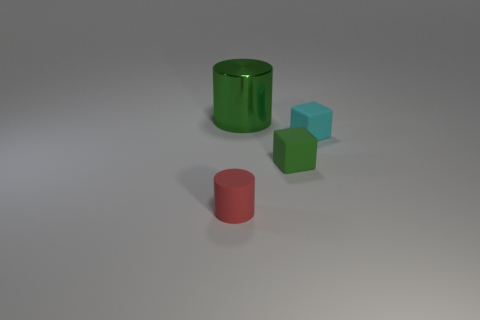Is there any other thing that has the same size as the green shiny object?
Your answer should be very brief. No. Are there any shiny blocks that have the same color as the large object?
Make the answer very short. No. Is the matte cylinder the same color as the metallic cylinder?
Ensure brevity in your answer.  No. There is a small cube that is the same color as the big metallic object; what is its material?
Provide a short and direct response. Rubber. What number of tiny gray rubber cubes are there?
Offer a very short reply. 0. Is the size of the green thing in front of the metal object the same as the big thing?
Offer a very short reply. No. How many shiny objects are small cyan objects or red balls?
Your answer should be compact. 0. There is a small rubber block that is in front of the small cyan matte cube; how many tiny red rubber cylinders are behind it?
Your answer should be compact. 0. The tiny matte thing that is both behind the tiny red rubber cylinder and in front of the small cyan thing has what shape?
Your response must be concise. Cube. The tiny object left of the cylinder that is behind the matte object that is in front of the small green thing is made of what material?
Provide a short and direct response. Rubber. 